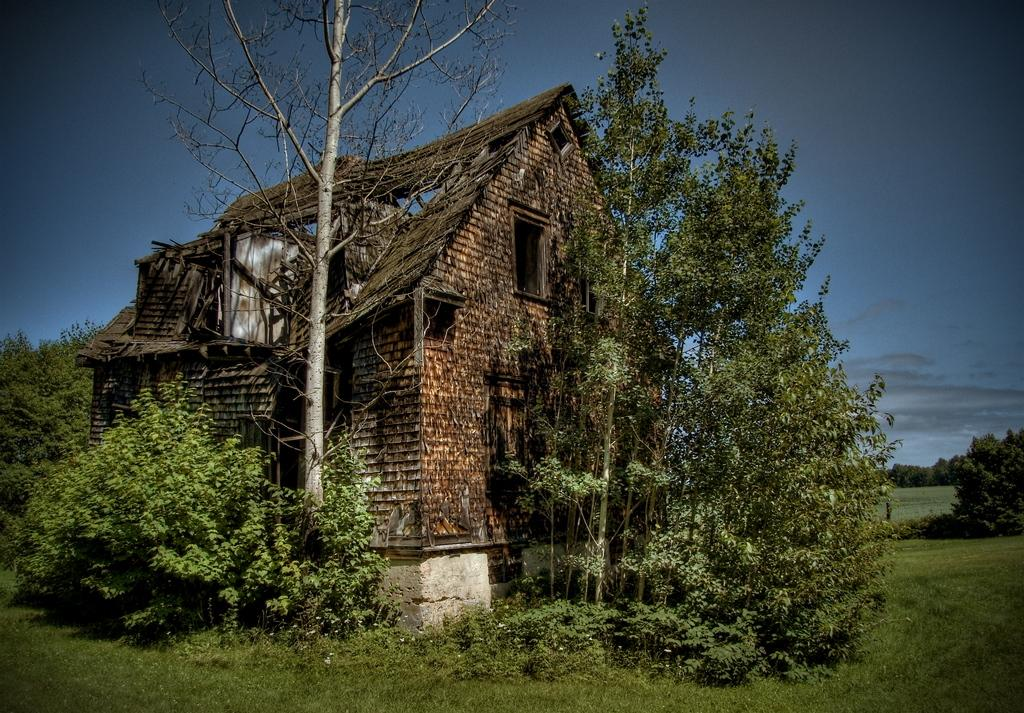What type of vegetation is at the bottom of the image? There is grass at the bottom of the image. What structure is located in the middle of the image? There is a house in the middle of the image. What other objects are in the middle of the image besides the house? There are trees in the middle of the image. What is visible at the top of the image? The sky is visible at the top of the image. What type of vegetation can be seen in the background of the image? There are trees in the background of the image. What type of education can be seen in the image? There is no reference to education in the image; it features grass, a house, trees, and the sky. What type of screw is visible in the image? There is no screw present in the image. 